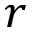Convert formula to latex. <formula><loc_0><loc_0><loc_500><loc_500>r</formula> 